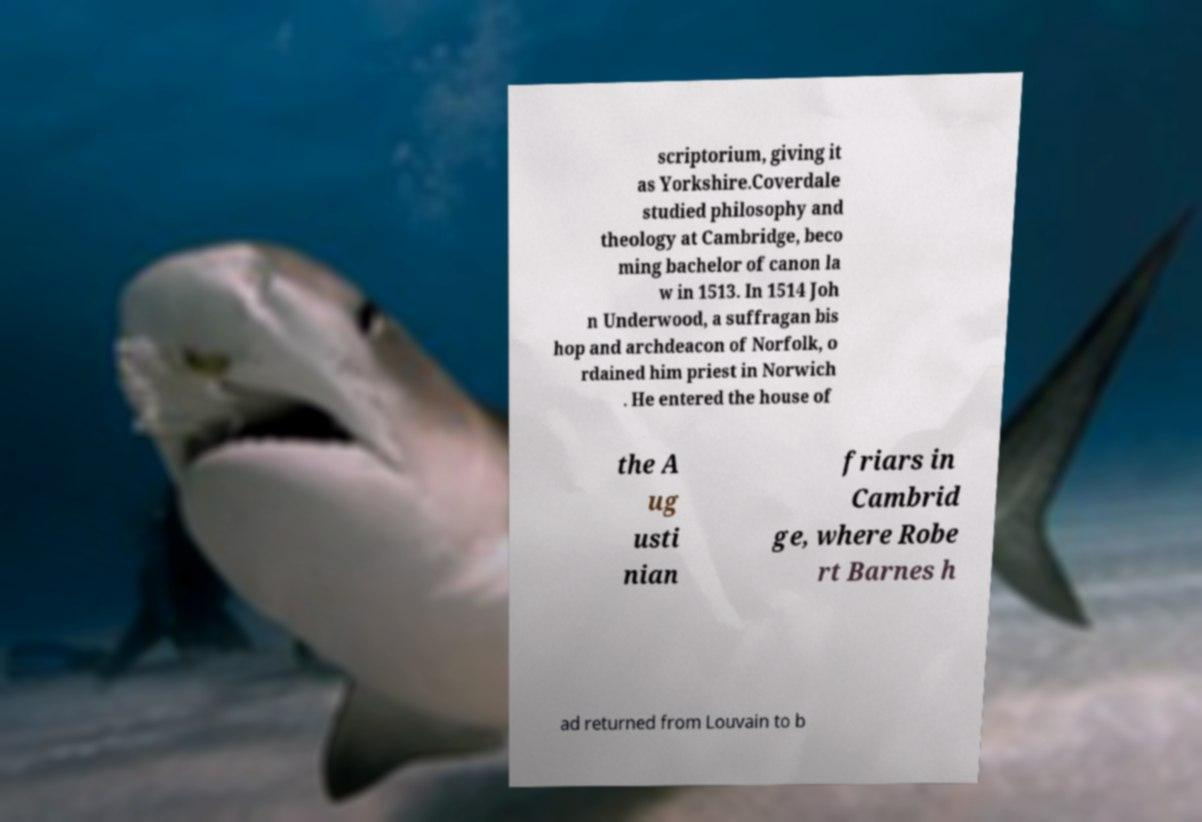Can you accurately transcribe the text from the provided image for me? scriptorium, giving it as Yorkshire.Coverdale studied philosophy and theology at Cambridge, beco ming bachelor of canon la w in 1513. In 1514 Joh n Underwood, a suffragan bis hop and archdeacon of Norfolk, o rdained him priest in Norwich . He entered the house of the A ug usti nian friars in Cambrid ge, where Robe rt Barnes h ad returned from Louvain to b 